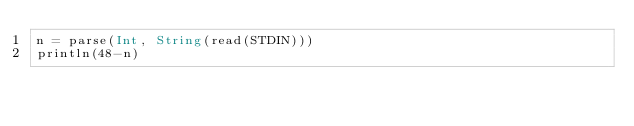Convert code to text. <code><loc_0><loc_0><loc_500><loc_500><_Julia_>n = parse(Int, String(read(STDIN)))
println(48-n)</code> 